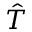Convert formula to latex. <formula><loc_0><loc_0><loc_500><loc_500>\hat { T }</formula> 